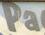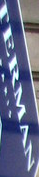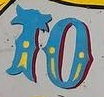What words can you see in these images in sequence, separated by a semicolon? Pa; TERMAN; TO 